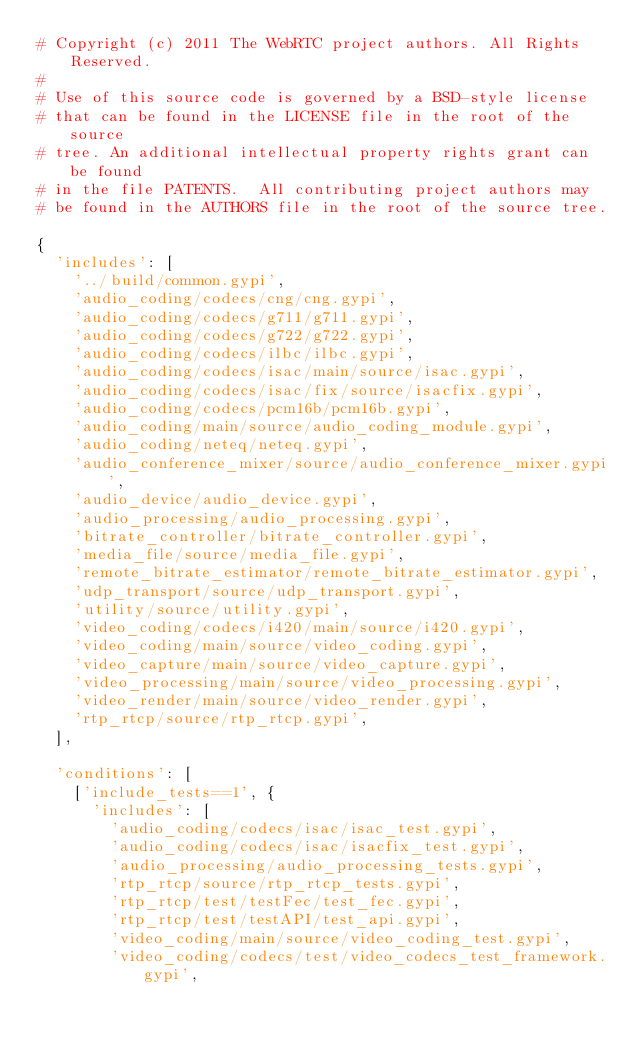<code> <loc_0><loc_0><loc_500><loc_500><_Python_># Copyright (c) 2011 The WebRTC project authors. All Rights Reserved.
#
# Use of this source code is governed by a BSD-style license
# that can be found in the LICENSE file in the root of the source
# tree. An additional intellectual property rights grant can be found
# in the file PATENTS.  All contributing project authors may
# be found in the AUTHORS file in the root of the source tree.

{
  'includes': [
    '../build/common.gypi',
    'audio_coding/codecs/cng/cng.gypi',
    'audio_coding/codecs/g711/g711.gypi',
    'audio_coding/codecs/g722/g722.gypi',
    'audio_coding/codecs/ilbc/ilbc.gypi',
    'audio_coding/codecs/isac/main/source/isac.gypi',
    'audio_coding/codecs/isac/fix/source/isacfix.gypi',
    'audio_coding/codecs/pcm16b/pcm16b.gypi',
    'audio_coding/main/source/audio_coding_module.gypi',
    'audio_coding/neteq/neteq.gypi',
    'audio_conference_mixer/source/audio_conference_mixer.gypi',
    'audio_device/audio_device.gypi',
    'audio_processing/audio_processing.gypi',
    'bitrate_controller/bitrate_controller.gypi',
    'media_file/source/media_file.gypi',
    'remote_bitrate_estimator/remote_bitrate_estimator.gypi',
    'udp_transport/source/udp_transport.gypi',
    'utility/source/utility.gypi',
    'video_coding/codecs/i420/main/source/i420.gypi',
    'video_coding/main/source/video_coding.gypi',
    'video_capture/main/source/video_capture.gypi',
    'video_processing/main/source/video_processing.gypi',
    'video_render/main/source/video_render.gypi',
    'rtp_rtcp/source/rtp_rtcp.gypi',
  ],

  'conditions': [
    ['include_tests==1', {
      'includes': [
        'audio_coding/codecs/isac/isac_test.gypi',
        'audio_coding/codecs/isac/isacfix_test.gypi',
        'audio_processing/audio_processing_tests.gypi',
        'rtp_rtcp/source/rtp_rtcp_tests.gypi',
        'rtp_rtcp/test/testFec/test_fec.gypi',
        'rtp_rtcp/test/testAPI/test_api.gypi',
        'video_coding/main/source/video_coding_test.gypi',
        'video_coding/codecs/test/video_codecs_test_framework.gypi',</code> 